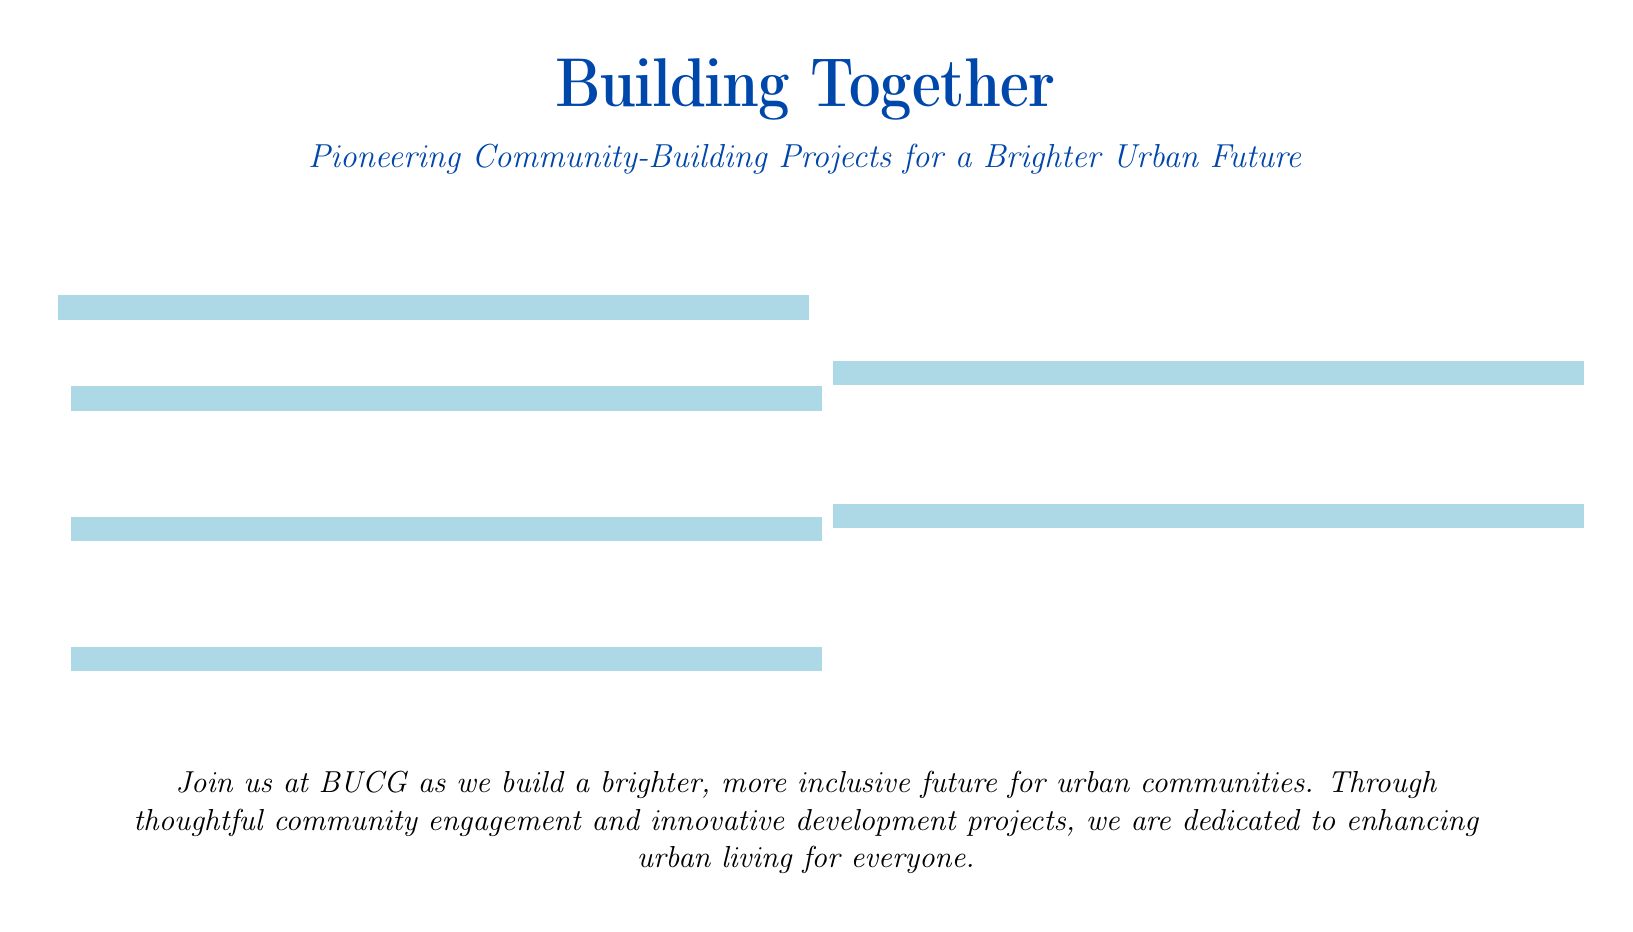What is the title of the advertisement? The title is prominently displayed in large font and captures the essence of the project’s vision.
Answer: Building Together What color is used for the heading of the advertisement? The heading is rendered in a specific RGB color that reflects the company's branding.
Answer: Blue What phrase is used to describe the project’s mission? The phrase encapsulates the aim of the community-building initiatives presented in the document.
Answer: Pioneering Community-Building Projects for a Brighter Urban Future What kind of engagement does BUCG promote? The document describes the type of activities and philosophies that BUCG is invested in regarding the community.
Answer: Community engagement What is the main purpose of BUCG as described in the document? The statement highlights the overall goal and motivation behind the projects initiated by BUCG in urban areas.
Answer: Enhancing urban living How many community-building projects are mentioned in the advertisement? The count of various projects or initiatives displayed in the advertisement reflects BUCG's commitment to community development.
Answer: Six 